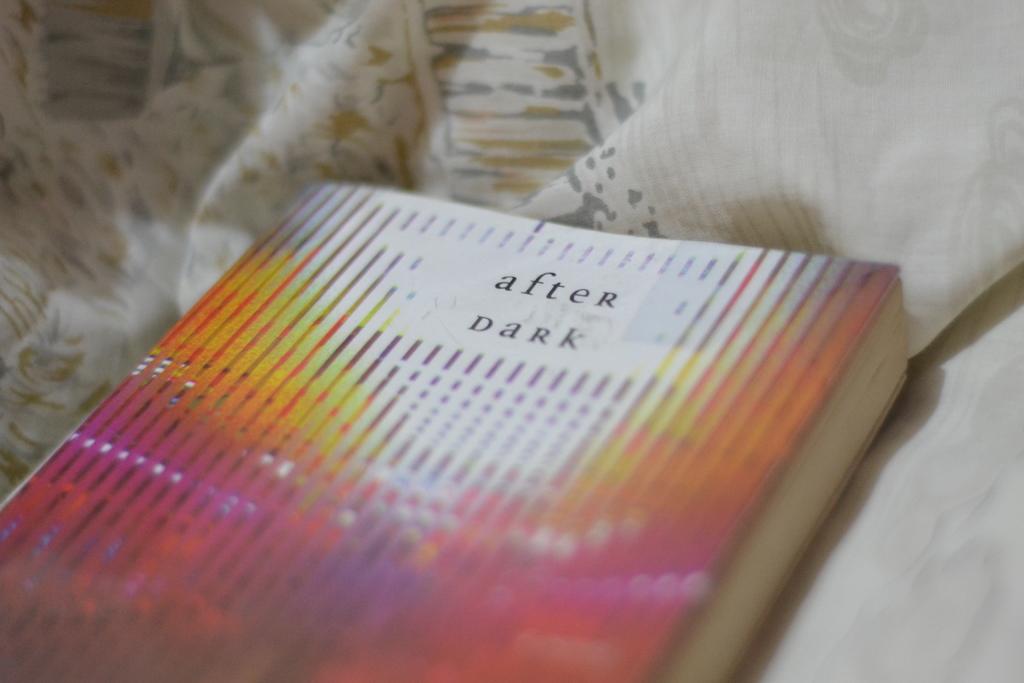What's the last word of the title of the book?
Your answer should be compact. Dark. Is this a bottle of stout?
Your answer should be very brief. No. 